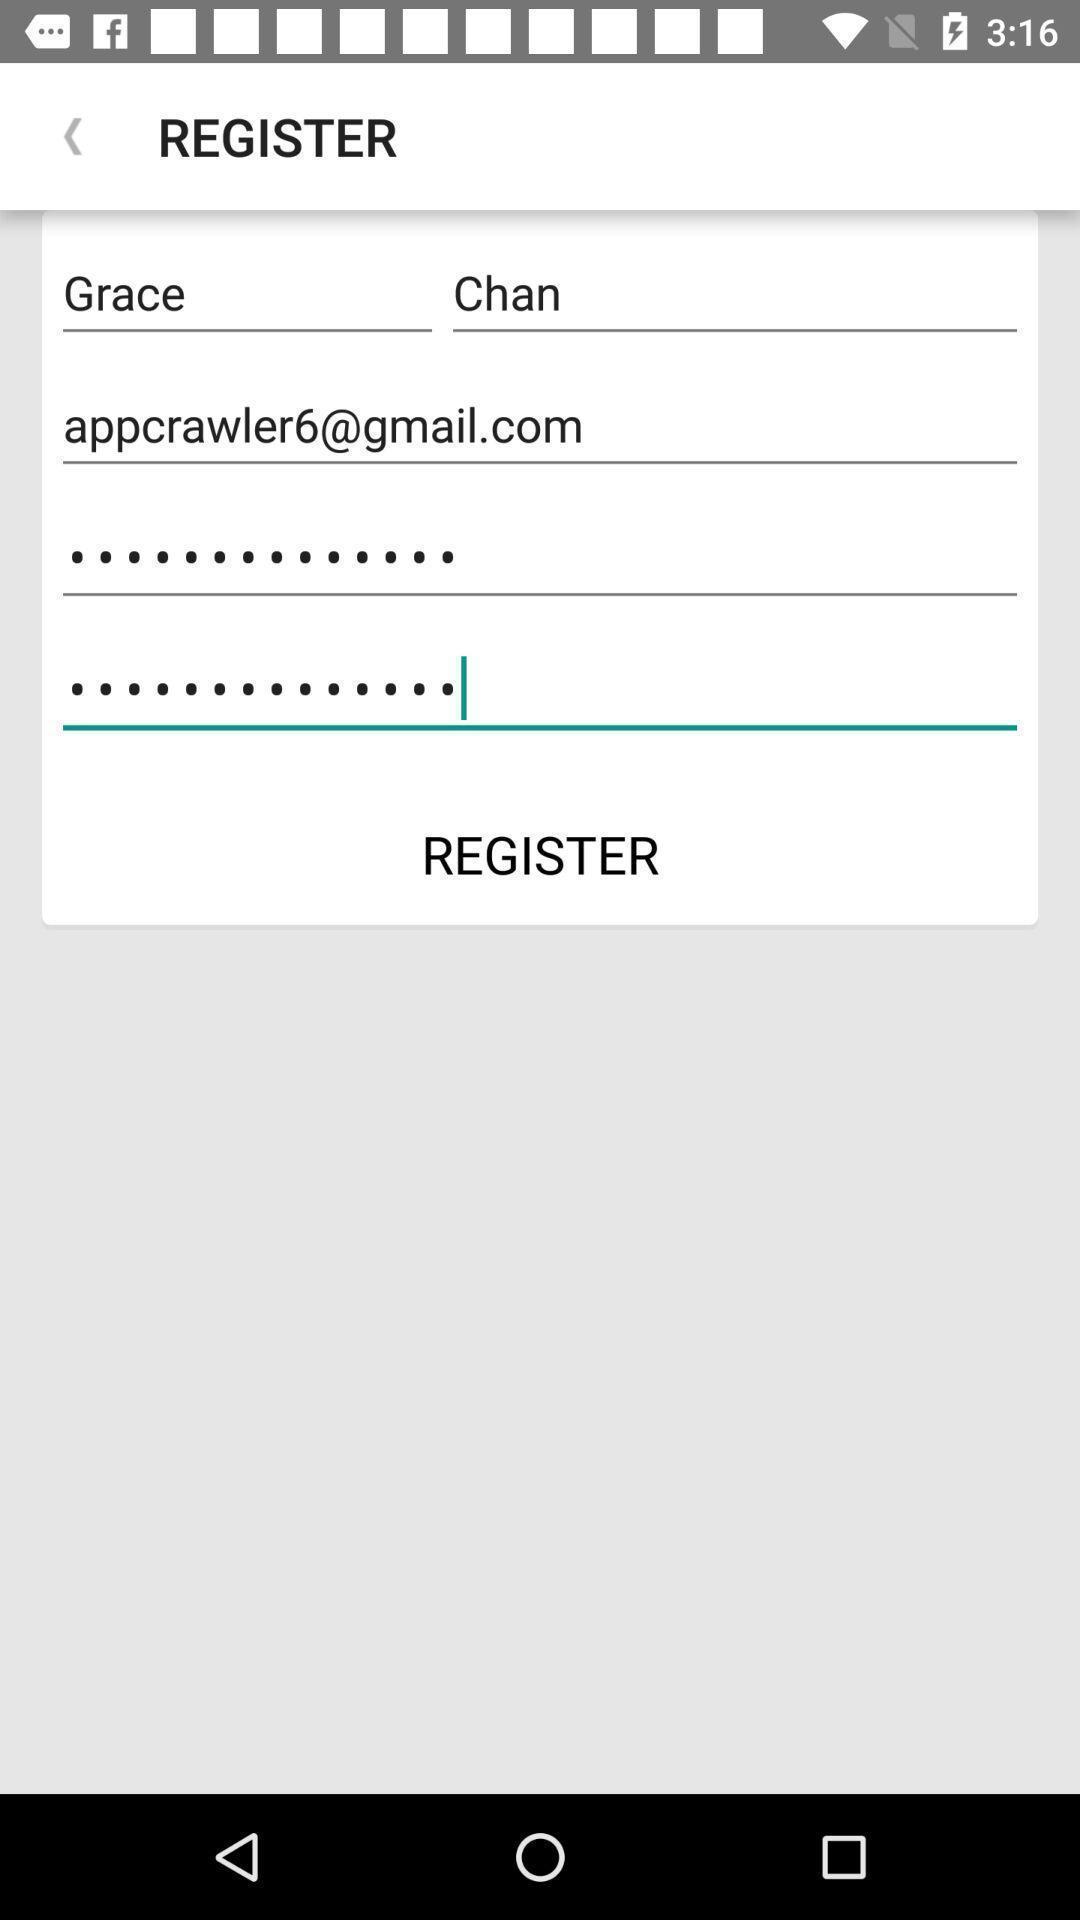Explain what's happening in this screen capture. Register page for a bills paying app. 